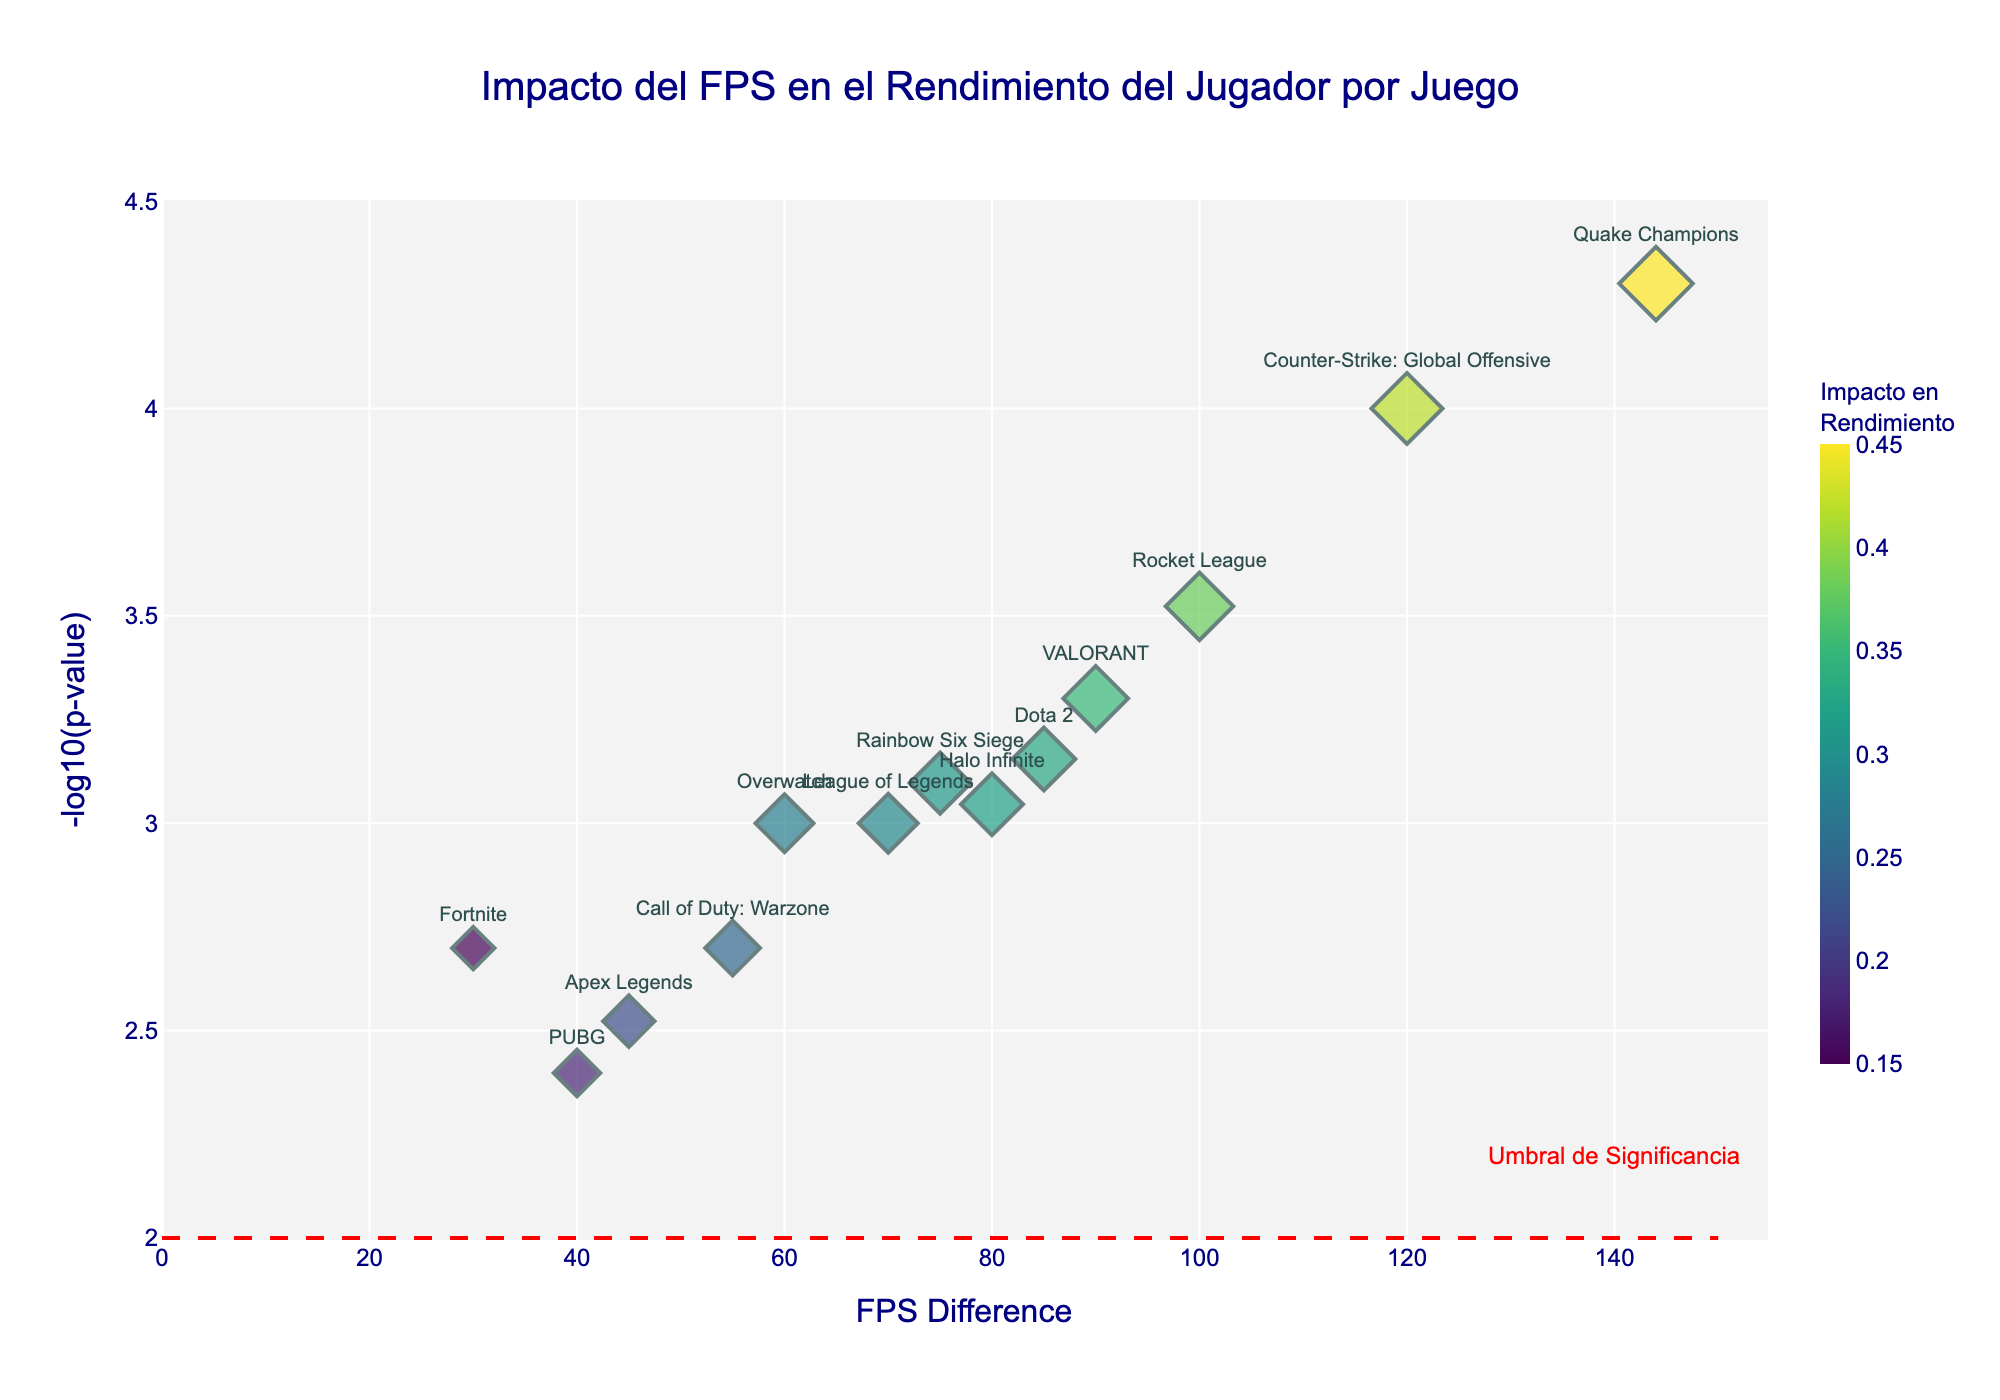What is the title of the plot? The title of the plot is located at the top and reads "Impacto del FPS en el Rendimiento del Jugador por Juego".
Answer: Impacto del FPS en el Rendimiento del Jugador por Juego What does the x-axis represent? The text label on the x-axis shows that it represents the "FPS Difference".
Answer: FPS Difference What is the -log10(p-value) for Quake Champions? Locate Quake Champions in the plot and check the y-axis value labelled as -log10(p-value). For Quake Champions, it is around 4.3.
Answer: 4.3 How many games have a performance impact greater than 0.3? Count the number of data points where the size of the marker (indicating performance impact) is greater than 0.3. Based on size and hover data, there are 9 such games.
Answer: 9 Which game has the highest FPS difference? Identify the game with the marker furthest to the right on the x-axis. The game with the highest FPS difference is Quake Champions, which has an FPS difference of 144.
Answer: Quake Champions Compare the performance impact between Counter-Strike: Global Offensive and League of Legends. Which is higher? Hover over the points for both games to see their performance impacts. Counter-Strike: Global Offensive has an impact of 0.42 whereas League of Legends has 0.29. Thus, Counter-Strike has a higher performance impact.
Answer: Counter-Strike: Global Offensive What is the significance threshold, and how is it indicated in the plot? The significance threshold is indicated by a red dashed horizontal line at y=2.0, with an annotation reading “Umbral de Significancia”.
Answer: 2.0 (red dashed line) How many games fall below the significance threshold? Count the number of data points below the red dashed line at y=2.0. There is one game below this threshold, which is PUBG.
Answer: 1 Which game shows the smallest p-value, and what is its fps_difference and performance_impact? Identify the game with the highest -log10(p-value) on the y-axis, which corresponds to the smallest p-value. This is Quake Champions with an fps_difference of 144 and a performance impact of 0.45.
Answer: Quake Champions, 144, 0.45 